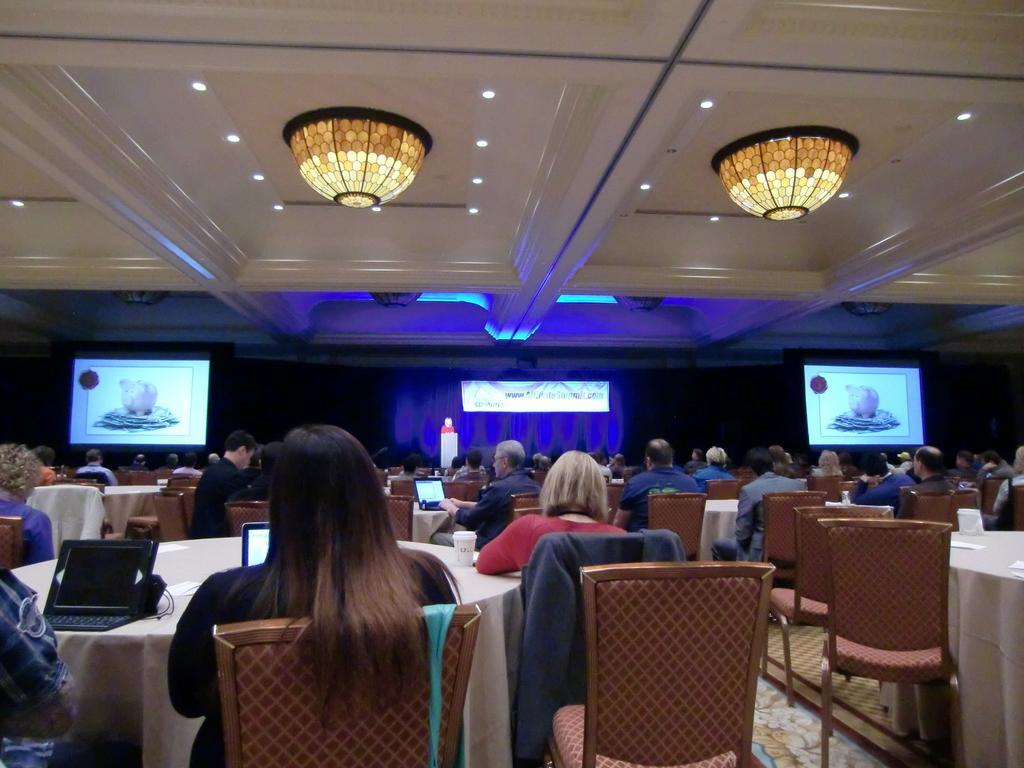How would you summarize this image in a sentence or two? In this picture we can see a group of people sitting on chairs, tables on the floor with laptops, glasses on it and in the background we can see screens, ceiling, some objects. 